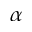Convert formula to latex. <formula><loc_0><loc_0><loc_500><loc_500>\alpha</formula> 